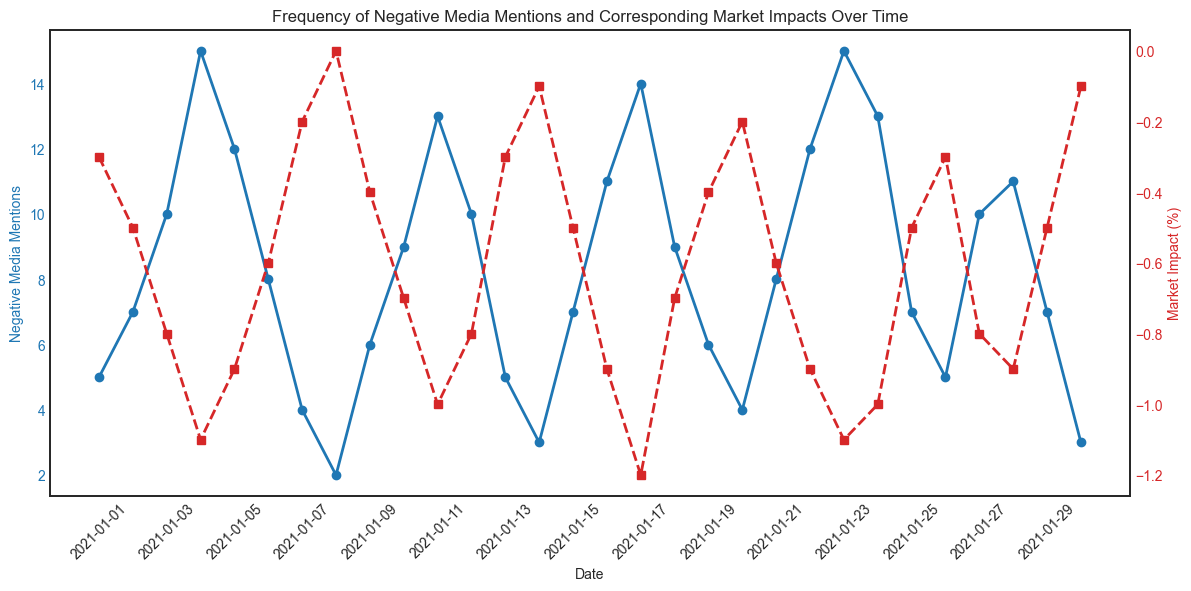What trend do you notice in the Negative Media Mentions from January 1st to January 4th? From January 1st to January 4th, the Negative Media Mentions consistently increase (5, 7, 10, 15) indicating a rising trend.
Answer: Increasing What is the market impact on January 8th, and how is it represented visually? On January 8th, the market impact is 0%. This is represented visually by the red line (representing market impact) intersecting the y-axis at 0.
Answer: 0% On which date did the Market Impact reach its lowest value? By examining the lowest point of the red (market impact) line, the lowest Market Impact (-1.2%) occurred on January 17th.
Answer: January 17th Compare the Negative Media Mentions on January 5th and January 15th. Which day had more mentions and by how much? January 5th had 12 mentions, while January 15th had 7 mentions. So January 5th had 5 more mentions than January 15th.
Answer: January 5th, 5 mentions more What’s the total number of Negative Media Mentions from January 20th to January 25th? Summing the mentions from January 20th to January 25th: 4 + 8 + 12 + 15 + 13 = 52.
Answer: 52 What’s the average Market Impact on the days when Negative Media Mentions exceeded 10? The dates where mentions exceeded 10 are Jan 4, Jan 11, Jan 16, Jan 17, Jan 22, Jan 23, and Jan 24. Market impacts: -1.1, -1.0, -0.9, -1.2, -0.9, -1.1, -1.0. Total = (-1.1 - 1.0 - 0.9 - 1.2 - 0.9 - 1.1 - 1.0) = -7.2. Average = -7.2 / 7 = -1.03.
Answer: -1.03 When did the Negative Media Mentions peak, and what was the corresponding market impact? The peak in Negative Media Mentions was on January 23rd with 15 mentions, and the corresponding market impact was -1.1%.
Answer: January 23rd, -1.1% Which has stricter fluctuation in terms of visual representation, Negative Media Mentions or Market Impact? From the visual representation, Negative Media Mentions (blue line) show larger spikes and fluctuations compared to Market Impact (red line), which has more gradual changes.
Answer: Negative Media Mentions Is there any relationship between the spikes in Negative Media Mentions and significant drops in Market Impact? Provide an example. Yes, it appears there is a relationship. For example, a spike in Negative Media Mentions to 15 on January 4th corresponds with a significant drop in Market Impact to -1.1%.
Answer: Yes, e.g., January 4th What conclusion can be drawn about handling negative media mentions based on market impact trends? The generally negative correlation between higher media mentions and more negative market impacts suggests prioritizing damage control to mitigate adverse market effects.
Answer: Prioritize damage control 